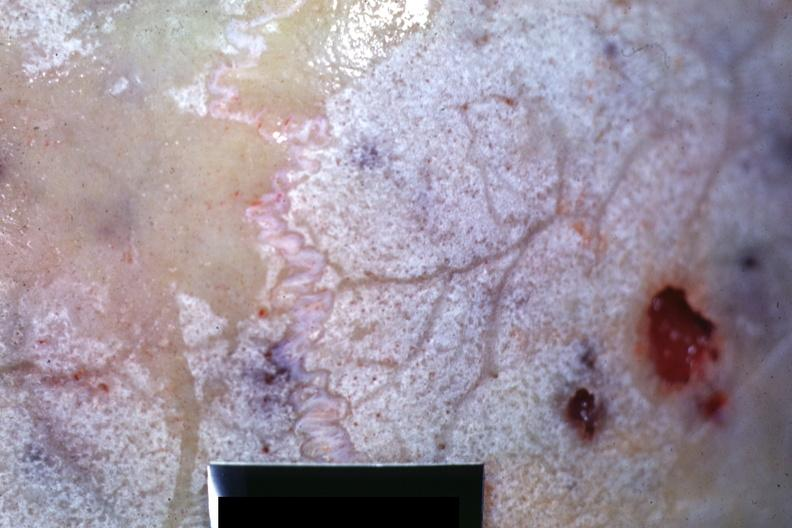does granulosa cell tumor show close-up view of bone with hemorrhagic excavations?
Answer the question using a single word or phrase. No 